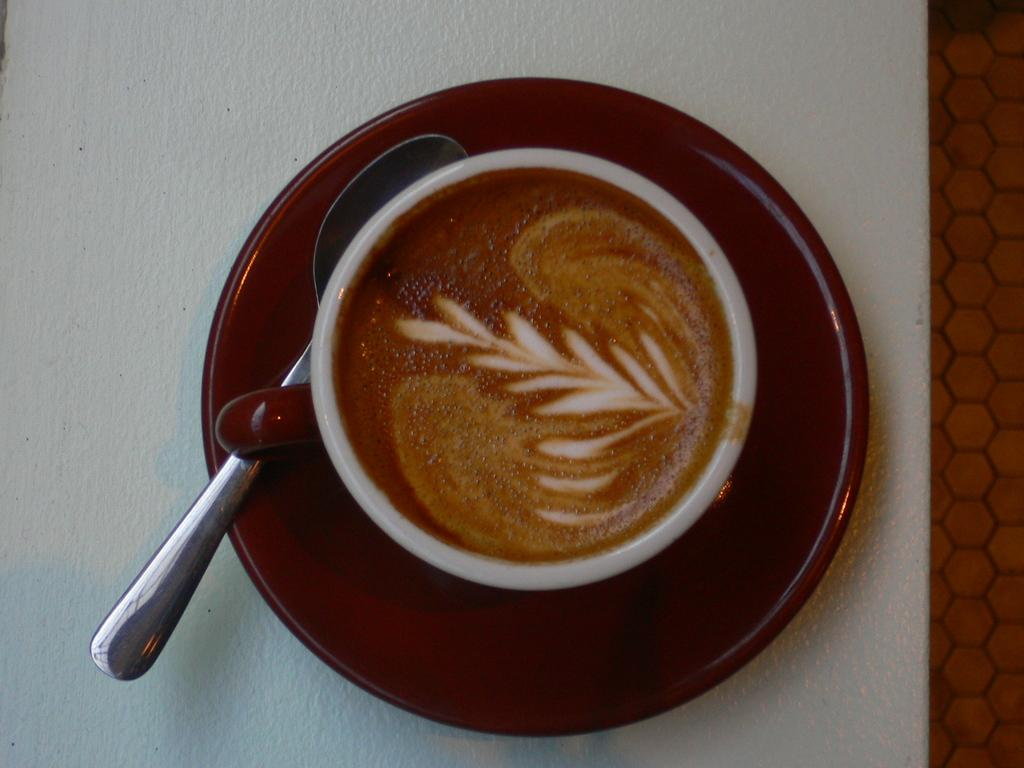What is in the cup that is visible in the image? There is a brown liquid in the cup. What color is the cup in the image? The cup is white. What is the saucer made of in the image? The saucer is brown. What type of butter is being used by the farmer in the image? There is no farmer or butter present in the image; it only features a cup with a brown liquid and a brown saucer. 